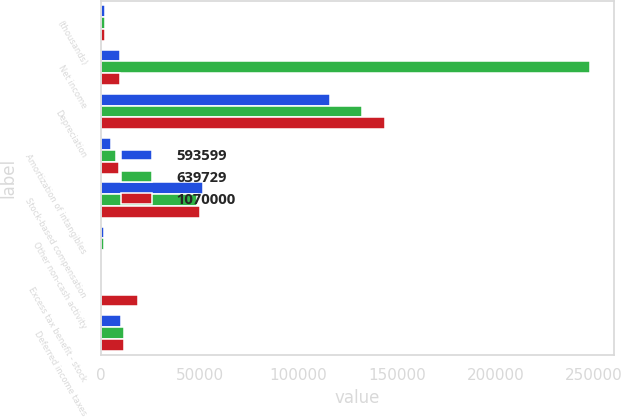<chart> <loc_0><loc_0><loc_500><loc_500><stacked_bar_chart><ecel><fcel>(thousands)<fcel>Net income<fcel>Depreciation<fcel>Amortization of intangibles<fcel>Stock-based compensation<fcel>Other non-cash activity<fcel>Excess tax benefit - stock<fcel>Deferred income taxes<nl><fcel>593599<fcel>2010<fcel>9558<fcel>116083<fcel>4828<fcel>51752<fcel>1662<fcel>317<fcel>9866<nl><fcel>639729<fcel>2009<fcel>247772<fcel>132493<fcel>7377<fcel>48613<fcel>1663<fcel>20<fcel>11595<nl><fcel>1.07e+06<fcel>2008<fcel>9558<fcel>144222<fcel>9250<fcel>50247<fcel>310<fcel>18586<fcel>11369<nl></chart> 